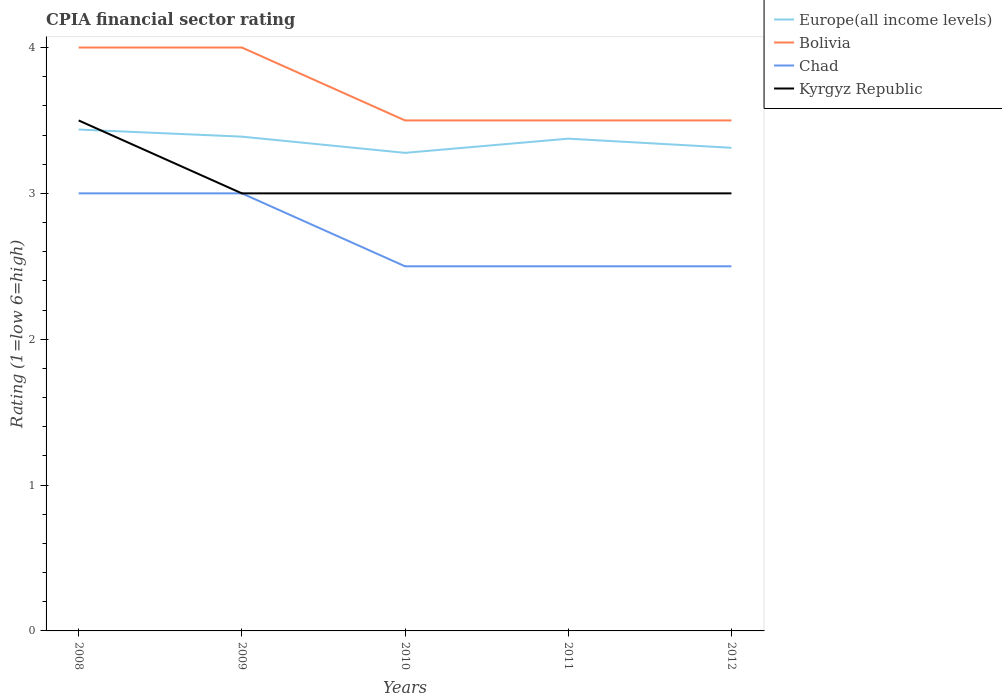How many different coloured lines are there?
Offer a very short reply. 4. Across all years, what is the maximum CPIA rating in Europe(all income levels)?
Offer a very short reply. 3.28. In which year was the CPIA rating in Europe(all income levels) maximum?
Your response must be concise. 2010. What is the total CPIA rating in Bolivia in the graph?
Your response must be concise. 0. What is the difference between the highest and the second highest CPIA rating in Europe(all income levels)?
Your answer should be compact. 0.16. What is the difference between the highest and the lowest CPIA rating in Kyrgyz Republic?
Provide a succinct answer. 1. Is the CPIA rating in Kyrgyz Republic strictly greater than the CPIA rating in Chad over the years?
Provide a short and direct response. No. How many years are there in the graph?
Your answer should be very brief. 5. What is the difference between two consecutive major ticks on the Y-axis?
Keep it short and to the point. 1. Are the values on the major ticks of Y-axis written in scientific E-notation?
Offer a terse response. No. Does the graph contain any zero values?
Offer a very short reply. No. Does the graph contain grids?
Give a very brief answer. No. Where does the legend appear in the graph?
Your answer should be very brief. Top right. What is the title of the graph?
Keep it short and to the point. CPIA financial sector rating. What is the label or title of the X-axis?
Provide a short and direct response. Years. What is the Rating (1=low 6=high) in Europe(all income levels) in 2008?
Provide a succinct answer. 3.44. What is the Rating (1=low 6=high) in Kyrgyz Republic in 2008?
Give a very brief answer. 3.5. What is the Rating (1=low 6=high) of Europe(all income levels) in 2009?
Ensure brevity in your answer.  3.39. What is the Rating (1=low 6=high) in Chad in 2009?
Your response must be concise. 3. What is the Rating (1=low 6=high) of Kyrgyz Republic in 2009?
Offer a terse response. 3. What is the Rating (1=low 6=high) in Europe(all income levels) in 2010?
Offer a terse response. 3.28. What is the Rating (1=low 6=high) of Bolivia in 2010?
Offer a very short reply. 3.5. What is the Rating (1=low 6=high) in Europe(all income levels) in 2011?
Offer a terse response. 3.38. What is the Rating (1=low 6=high) in Bolivia in 2011?
Your answer should be very brief. 3.5. What is the Rating (1=low 6=high) of Europe(all income levels) in 2012?
Give a very brief answer. 3.31. What is the Rating (1=low 6=high) of Chad in 2012?
Provide a short and direct response. 2.5. Across all years, what is the maximum Rating (1=low 6=high) of Europe(all income levels)?
Offer a terse response. 3.44. Across all years, what is the maximum Rating (1=low 6=high) of Chad?
Offer a very short reply. 3. Across all years, what is the minimum Rating (1=low 6=high) of Europe(all income levels)?
Provide a succinct answer. 3.28. Across all years, what is the minimum Rating (1=low 6=high) of Bolivia?
Offer a very short reply. 3.5. Across all years, what is the minimum Rating (1=low 6=high) of Chad?
Keep it short and to the point. 2.5. What is the total Rating (1=low 6=high) in Europe(all income levels) in the graph?
Ensure brevity in your answer.  16.79. What is the total Rating (1=low 6=high) of Bolivia in the graph?
Your response must be concise. 18.5. What is the total Rating (1=low 6=high) in Kyrgyz Republic in the graph?
Keep it short and to the point. 15.5. What is the difference between the Rating (1=low 6=high) of Europe(all income levels) in 2008 and that in 2009?
Provide a succinct answer. 0.05. What is the difference between the Rating (1=low 6=high) of Chad in 2008 and that in 2009?
Ensure brevity in your answer.  0. What is the difference between the Rating (1=low 6=high) in Kyrgyz Republic in 2008 and that in 2009?
Provide a succinct answer. 0.5. What is the difference between the Rating (1=low 6=high) of Europe(all income levels) in 2008 and that in 2010?
Your answer should be very brief. 0.16. What is the difference between the Rating (1=low 6=high) in Chad in 2008 and that in 2010?
Give a very brief answer. 0.5. What is the difference between the Rating (1=low 6=high) of Kyrgyz Republic in 2008 and that in 2010?
Provide a short and direct response. 0.5. What is the difference between the Rating (1=low 6=high) of Europe(all income levels) in 2008 and that in 2011?
Give a very brief answer. 0.06. What is the difference between the Rating (1=low 6=high) of Bolivia in 2008 and that in 2011?
Offer a very short reply. 0.5. What is the difference between the Rating (1=low 6=high) in Bolivia in 2008 and that in 2012?
Your answer should be compact. 0.5. What is the difference between the Rating (1=low 6=high) in Chad in 2008 and that in 2012?
Provide a short and direct response. 0.5. What is the difference between the Rating (1=low 6=high) in Kyrgyz Republic in 2008 and that in 2012?
Keep it short and to the point. 0.5. What is the difference between the Rating (1=low 6=high) of Chad in 2009 and that in 2010?
Provide a succinct answer. 0.5. What is the difference between the Rating (1=low 6=high) of Kyrgyz Republic in 2009 and that in 2010?
Give a very brief answer. 0. What is the difference between the Rating (1=low 6=high) in Europe(all income levels) in 2009 and that in 2011?
Provide a succinct answer. 0.01. What is the difference between the Rating (1=low 6=high) in Chad in 2009 and that in 2011?
Offer a very short reply. 0.5. What is the difference between the Rating (1=low 6=high) of Europe(all income levels) in 2009 and that in 2012?
Provide a succinct answer. 0.08. What is the difference between the Rating (1=low 6=high) in Europe(all income levels) in 2010 and that in 2011?
Offer a very short reply. -0.1. What is the difference between the Rating (1=low 6=high) of Chad in 2010 and that in 2011?
Your answer should be compact. 0. What is the difference between the Rating (1=low 6=high) of Europe(all income levels) in 2010 and that in 2012?
Make the answer very short. -0.03. What is the difference between the Rating (1=low 6=high) in Europe(all income levels) in 2011 and that in 2012?
Keep it short and to the point. 0.06. What is the difference between the Rating (1=low 6=high) in Bolivia in 2011 and that in 2012?
Your response must be concise. 0. What is the difference between the Rating (1=low 6=high) in Chad in 2011 and that in 2012?
Provide a succinct answer. 0. What is the difference between the Rating (1=low 6=high) in Kyrgyz Republic in 2011 and that in 2012?
Keep it short and to the point. 0. What is the difference between the Rating (1=low 6=high) of Europe(all income levels) in 2008 and the Rating (1=low 6=high) of Bolivia in 2009?
Keep it short and to the point. -0.56. What is the difference between the Rating (1=low 6=high) in Europe(all income levels) in 2008 and the Rating (1=low 6=high) in Chad in 2009?
Make the answer very short. 0.44. What is the difference between the Rating (1=low 6=high) of Europe(all income levels) in 2008 and the Rating (1=low 6=high) of Kyrgyz Republic in 2009?
Your response must be concise. 0.44. What is the difference between the Rating (1=low 6=high) of Bolivia in 2008 and the Rating (1=low 6=high) of Chad in 2009?
Ensure brevity in your answer.  1. What is the difference between the Rating (1=low 6=high) of Chad in 2008 and the Rating (1=low 6=high) of Kyrgyz Republic in 2009?
Make the answer very short. 0. What is the difference between the Rating (1=low 6=high) in Europe(all income levels) in 2008 and the Rating (1=low 6=high) in Bolivia in 2010?
Your answer should be compact. -0.06. What is the difference between the Rating (1=low 6=high) in Europe(all income levels) in 2008 and the Rating (1=low 6=high) in Kyrgyz Republic in 2010?
Make the answer very short. 0.44. What is the difference between the Rating (1=low 6=high) of Bolivia in 2008 and the Rating (1=low 6=high) of Chad in 2010?
Make the answer very short. 1.5. What is the difference between the Rating (1=low 6=high) in Chad in 2008 and the Rating (1=low 6=high) in Kyrgyz Republic in 2010?
Offer a terse response. 0. What is the difference between the Rating (1=low 6=high) in Europe(all income levels) in 2008 and the Rating (1=low 6=high) in Bolivia in 2011?
Offer a very short reply. -0.06. What is the difference between the Rating (1=low 6=high) in Europe(all income levels) in 2008 and the Rating (1=low 6=high) in Chad in 2011?
Give a very brief answer. 0.94. What is the difference between the Rating (1=low 6=high) of Europe(all income levels) in 2008 and the Rating (1=low 6=high) of Kyrgyz Republic in 2011?
Provide a short and direct response. 0.44. What is the difference between the Rating (1=low 6=high) of Bolivia in 2008 and the Rating (1=low 6=high) of Kyrgyz Republic in 2011?
Give a very brief answer. 1. What is the difference between the Rating (1=low 6=high) in Chad in 2008 and the Rating (1=low 6=high) in Kyrgyz Republic in 2011?
Provide a short and direct response. 0. What is the difference between the Rating (1=low 6=high) of Europe(all income levels) in 2008 and the Rating (1=low 6=high) of Bolivia in 2012?
Ensure brevity in your answer.  -0.06. What is the difference between the Rating (1=low 6=high) of Europe(all income levels) in 2008 and the Rating (1=low 6=high) of Kyrgyz Republic in 2012?
Keep it short and to the point. 0.44. What is the difference between the Rating (1=low 6=high) of Bolivia in 2008 and the Rating (1=low 6=high) of Kyrgyz Republic in 2012?
Provide a short and direct response. 1. What is the difference between the Rating (1=low 6=high) in Chad in 2008 and the Rating (1=low 6=high) in Kyrgyz Republic in 2012?
Offer a very short reply. 0. What is the difference between the Rating (1=low 6=high) in Europe(all income levels) in 2009 and the Rating (1=low 6=high) in Bolivia in 2010?
Your answer should be compact. -0.11. What is the difference between the Rating (1=low 6=high) in Europe(all income levels) in 2009 and the Rating (1=low 6=high) in Chad in 2010?
Your answer should be compact. 0.89. What is the difference between the Rating (1=low 6=high) of Europe(all income levels) in 2009 and the Rating (1=low 6=high) of Kyrgyz Republic in 2010?
Give a very brief answer. 0.39. What is the difference between the Rating (1=low 6=high) in Bolivia in 2009 and the Rating (1=low 6=high) in Chad in 2010?
Your answer should be very brief. 1.5. What is the difference between the Rating (1=low 6=high) of Bolivia in 2009 and the Rating (1=low 6=high) of Kyrgyz Republic in 2010?
Your answer should be very brief. 1. What is the difference between the Rating (1=low 6=high) of Chad in 2009 and the Rating (1=low 6=high) of Kyrgyz Republic in 2010?
Your answer should be compact. 0. What is the difference between the Rating (1=low 6=high) of Europe(all income levels) in 2009 and the Rating (1=low 6=high) of Bolivia in 2011?
Offer a very short reply. -0.11. What is the difference between the Rating (1=low 6=high) in Europe(all income levels) in 2009 and the Rating (1=low 6=high) in Chad in 2011?
Give a very brief answer. 0.89. What is the difference between the Rating (1=low 6=high) of Europe(all income levels) in 2009 and the Rating (1=low 6=high) of Kyrgyz Republic in 2011?
Provide a succinct answer. 0.39. What is the difference between the Rating (1=low 6=high) of Bolivia in 2009 and the Rating (1=low 6=high) of Chad in 2011?
Your answer should be very brief. 1.5. What is the difference between the Rating (1=low 6=high) of Chad in 2009 and the Rating (1=low 6=high) of Kyrgyz Republic in 2011?
Your answer should be very brief. 0. What is the difference between the Rating (1=low 6=high) in Europe(all income levels) in 2009 and the Rating (1=low 6=high) in Bolivia in 2012?
Provide a short and direct response. -0.11. What is the difference between the Rating (1=low 6=high) of Europe(all income levels) in 2009 and the Rating (1=low 6=high) of Kyrgyz Republic in 2012?
Keep it short and to the point. 0.39. What is the difference between the Rating (1=low 6=high) in Europe(all income levels) in 2010 and the Rating (1=low 6=high) in Bolivia in 2011?
Provide a succinct answer. -0.22. What is the difference between the Rating (1=low 6=high) of Europe(all income levels) in 2010 and the Rating (1=low 6=high) of Kyrgyz Republic in 2011?
Give a very brief answer. 0.28. What is the difference between the Rating (1=low 6=high) of Bolivia in 2010 and the Rating (1=low 6=high) of Chad in 2011?
Provide a short and direct response. 1. What is the difference between the Rating (1=low 6=high) in Chad in 2010 and the Rating (1=low 6=high) in Kyrgyz Republic in 2011?
Make the answer very short. -0.5. What is the difference between the Rating (1=low 6=high) of Europe(all income levels) in 2010 and the Rating (1=low 6=high) of Bolivia in 2012?
Your response must be concise. -0.22. What is the difference between the Rating (1=low 6=high) of Europe(all income levels) in 2010 and the Rating (1=low 6=high) of Chad in 2012?
Offer a very short reply. 0.78. What is the difference between the Rating (1=low 6=high) in Europe(all income levels) in 2010 and the Rating (1=low 6=high) in Kyrgyz Republic in 2012?
Offer a very short reply. 0.28. What is the difference between the Rating (1=low 6=high) of Europe(all income levels) in 2011 and the Rating (1=low 6=high) of Bolivia in 2012?
Give a very brief answer. -0.12. What is the difference between the Rating (1=low 6=high) of Europe(all income levels) in 2011 and the Rating (1=low 6=high) of Chad in 2012?
Your answer should be compact. 0.88. What is the difference between the Rating (1=low 6=high) in Europe(all income levels) in 2011 and the Rating (1=low 6=high) in Kyrgyz Republic in 2012?
Provide a succinct answer. 0.38. What is the difference between the Rating (1=low 6=high) in Bolivia in 2011 and the Rating (1=low 6=high) in Chad in 2012?
Make the answer very short. 1. What is the difference between the Rating (1=low 6=high) of Bolivia in 2011 and the Rating (1=low 6=high) of Kyrgyz Republic in 2012?
Keep it short and to the point. 0.5. What is the average Rating (1=low 6=high) in Europe(all income levels) per year?
Make the answer very short. 3.36. What is the average Rating (1=low 6=high) of Bolivia per year?
Ensure brevity in your answer.  3.7. What is the average Rating (1=low 6=high) of Chad per year?
Offer a terse response. 2.7. In the year 2008, what is the difference between the Rating (1=low 6=high) in Europe(all income levels) and Rating (1=low 6=high) in Bolivia?
Offer a terse response. -0.56. In the year 2008, what is the difference between the Rating (1=low 6=high) in Europe(all income levels) and Rating (1=low 6=high) in Chad?
Provide a short and direct response. 0.44. In the year 2008, what is the difference between the Rating (1=low 6=high) of Europe(all income levels) and Rating (1=low 6=high) of Kyrgyz Republic?
Make the answer very short. -0.06. In the year 2008, what is the difference between the Rating (1=low 6=high) of Bolivia and Rating (1=low 6=high) of Chad?
Ensure brevity in your answer.  1. In the year 2008, what is the difference between the Rating (1=low 6=high) in Bolivia and Rating (1=low 6=high) in Kyrgyz Republic?
Your answer should be very brief. 0.5. In the year 2008, what is the difference between the Rating (1=low 6=high) in Chad and Rating (1=low 6=high) in Kyrgyz Republic?
Your response must be concise. -0.5. In the year 2009, what is the difference between the Rating (1=low 6=high) in Europe(all income levels) and Rating (1=low 6=high) in Bolivia?
Give a very brief answer. -0.61. In the year 2009, what is the difference between the Rating (1=low 6=high) of Europe(all income levels) and Rating (1=low 6=high) of Chad?
Offer a terse response. 0.39. In the year 2009, what is the difference between the Rating (1=low 6=high) of Europe(all income levels) and Rating (1=low 6=high) of Kyrgyz Republic?
Keep it short and to the point. 0.39. In the year 2009, what is the difference between the Rating (1=low 6=high) of Bolivia and Rating (1=low 6=high) of Chad?
Give a very brief answer. 1. In the year 2009, what is the difference between the Rating (1=low 6=high) in Bolivia and Rating (1=low 6=high) in Kyrgyz Republic?
Offer a terse response. 1. In the year 2009, what is the difference between the Rating (1=low 6=high) of Chad and Rating (1=low 6=high) of Kyrgyz Republic?
Your answer should be compact. 0. In the year 2010, what is the difference between the Rating (1=low 6=high) in Europe(all income levels) and Rating (1=low 6=high) in Bolivia?
Offer a terse response. -0.22. In the year 2010, what is the difference between the Rating (1=low 6=high) of Europe(all income levels) and Rating (1=low 6=high) of Kyrgyz Republic?
Provide a short and direct response. 0.28. In the year 2010, what is the difference between the Rating (1=low 6=high) of Bolivia and Rating (1=low 6=high) of Kyrgyz Republic?
Your response must be concise. 0.5. In the year 2010, what is the difference between the Rating (1=low 6=high) in Chad and Rating (1=low 6=high) in Kyrgyz Republic?
Keep it short and to the point. -0.5. In the year 2011, what is the difference between the Rating (1=low 6=high) of Europe(all income levels) and Rating (1=low 6=high) of Bolivia?
Ensure brevity in your answer.  -0.12. In the year 2011, what is the difference between the Rating (1=low 6=high) in Europe(all income levels) and Rating (1=low 6=high) in Chad?
Offer a terse response. 0.88. In the year 2011, what is the difference between the Rating (1=low 6=high) of Bolivia and Rating (1=low 6=high) of Chad?
Provide a short and direct response. 1. In the year 2011, what is the difference between the Rating (1=low 6=high) of Chad and Rating (1=low 6=high) of Kyrgyz Republic?
Offer a terse response. -0.5. In the year 2012, what is the difference between the Rating (1=low 6=high) in Europe(all income levels) and Rating (1=low 6=high) in Bolivia?
Give a very brief answer. -0.19. In the year 2012, what is the difference between the Rating (1=low 6=high) in Europe(all income levels) and Rating (1=low 6=high) in Chad?
Offer a terse response. 0.81. In the year 2012, what is the difference between the Rating (1=low 6=high) in Europe(all income levels) and Rating (1=low 6=high) in Kyrgyz Republic?
Your response must be concise. 0.31. In the year 2012, what is the difference between the Rating (1=low 6=high) of Bolivia and Rating (1=low 6=high) of Chad?
Offer a terse response. 1. In the year 2012, what is the difference between the Rating (1=low 6=high) in Bolivia and Rating (1=low 6=high) in Kyrgyz Republic?
Keep it short and to the point. 0.5. What is the ratio of the Rating (1=low 6=high) of Europe(all income levels) in 2008 to that in 2009?
Make the answer very short. 1.01. What is the ratio of the Rating (1=low 6=high) of Europe(all income levels) in 2008 to that in 2010?
Provide a short and direct response. 1.05. What is the ratio of the Rating (1=low 6=high) of Chad in 2008 to that in 2010?
Make the answer very short. 1.2. What is the ratio of the Rating (1=low 6=high) of Kyrgyz Republic in 2008 to that in 2010?
Keep it short and to the point. 1.17. What is the ratio of the Rating (1=low 6=high) in Europe(all income levels) in 2008 to that in 2011?
Give a very brief answer. 1.02. What is the ratio of the Rating (1=low 6=high) of Chad in 2008 to that in 2011?
Your response must be concise. 1.2. What is the ratio of the Rating (1=low 6=high) in Kyrgyz Republic in 2008 to that in 2011?
Provide a succinct answer. 1.17. What is the ratio of the Rating (1=low 6=high) of Europe(all income levels) in 2008 to that in 2012?
Make the answer very short. 1.04. What is the ratio of the Rating (1=low 6=high) of Chad in 2008 to that in 2012?
Your response must be concise. 1.2. What is the ratio of the Rating (1=low 6=high) in Kyrgyz Republic in 2008 to that in 2012?
Your answer should be compact. 1.17. What is the ratio of the Rating (1=low 6=high) of Europe(all income levels) in 2009 to that in 2010?
Offer a very short reply. 1.03. What is the ratio of the Rating (1=low 6=high) of Kyrgyz Republic in 2009 to that in 2010?
Your response must be concise. 1. What is the ratio of the Rating (1=low 6=high) of Bolivia in 2009 to that in 2011?
Your response must be concise. 1.14. What is the ratio of the Rating (1=low 6=high) in Europe(all income levels) in 2009 to that in 2012?
Your answer should be compact. 1.02. What is the ratio of the Rating (1=low 6=high) of Europe(all income levels) in 2010 to that in 2011?
Provide a short and direct response. 0.97. What is the ratio of the Rating (1=low 6=high) of Chad in 2010 to that in 2011?
Keep it short and to the point. 1. What is the ratio of the Rating (1=low 6=high) in Kyrgyz Republic in 2010 to that in 2011?
Give a very brief answer. 1. What is the ratio of the Rating (1=low 6=high) of Bolivia in 2010 to that in 2012?
Make the answer very short. 1. What is the ratio of the Rating (1=low 6=high) in Europe(all income levels) in 2011 to that in 2012?
Provide a short and direct response. 1.02. What is the difference between the highest and the second highest Rating (1=low 6=high) of Europe(all income levels)?
Offer a very short reply. 0.05. What is the difference between the highest and the lowest Rating (1=low 6=high) in Europe(all income levels)?
Offer a terse response. 0.16. What is the difference between the highest and the lowest Rating (1=low 6=high) of Bolivia?
Your answer should be very brief. 0.5. What is the difference between the highest and the lowest Rating (1=low 6=high) of Chad?
Offer a terse response. 0.5. What is the difference between the highest and the lowest Rating (1=low 6=high) in Kyrgyz Republic?
Your response must be concise. 0.5. 